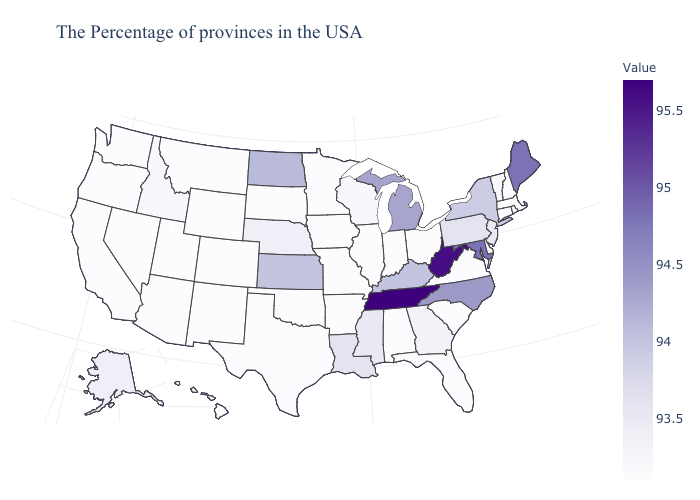Does South Dakota have the highest value in the USA?
Answer briefly. No. Among the states that border Maine , which have the highest value?
Keep it brief. New Hampshire. Among the states that border Kentucky , does Virginia have the highest value?
Short answer required. No. 